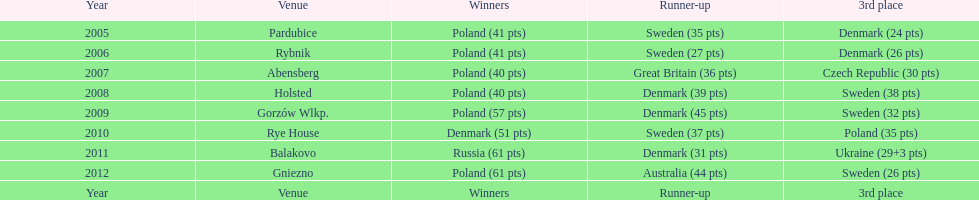Parse the full table. {'header': ['Year', 'Venue', 'Winners', 'Runner-up', '3rd place'], 'rows': [['2005', 'Pardubice', 'Poland (41 pts)', 'Sweden (35 pts)', 'Denmark (24 pts)'], ['2006', 'Rybnik', 'Poland (41 pts)', 'Sweden (27 pts)', 'Denmark (26 pts)'], ['2007', 'Abensberg', 'Poland (40 pts)', 'Great Britain (36 pts)', 'Czech Republic (30 pts)'], ['2008', 'Holsted', 'Poland (40 pts)', 'Denmark (39 pts)', 'Sweden (38 pts)'], ['2009', 'Gorzów Wlkp.', 'Poland (57 pts)', 'Denmark (45 pts)', 'Sweden (32 pts)'], ['2010', 'Rye House', 'Denmark (51 pts)', 'Sweden (37 pts)', 'Poland (35 pts)'], ['2011', 'Balakovo', 'Russia (61 pts)', 'Denmark (31 pts)', 'Ukraine (29+3 pts)'], ['2012', 'Gniezno', 'Poland (61 pts)', 'Australia (44 pts)', 'Sweden (26 pts)'], ['Year', 'Venue', 'Winners', 'Runner-up', '3rd place']]} From 2008 onwards, what is the sum of points earned by the winning teams? 230. 